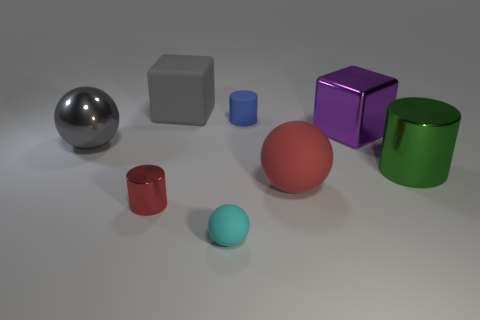Subtract all blue rubber cylinders. How many cylinders are left? 2 Add 1 red metal cylinders. How many objects exist? 9 Subtract all cyan spheres. How many spheres are left? 2 Subtract all blue balls. Subtract all green cubes. How many balls are left? 3 Subtract all cylinders. How many objects are left? 5 Subtract all metal balls. Subtract all tiny purple cylinders. How many objects are left? 7 Add 7 gray objects. How many gray objects are left? 9 Add 3 large green things. How many large green things exist? 4 Subtract 1 red cylinders. How many objects are left? 7 